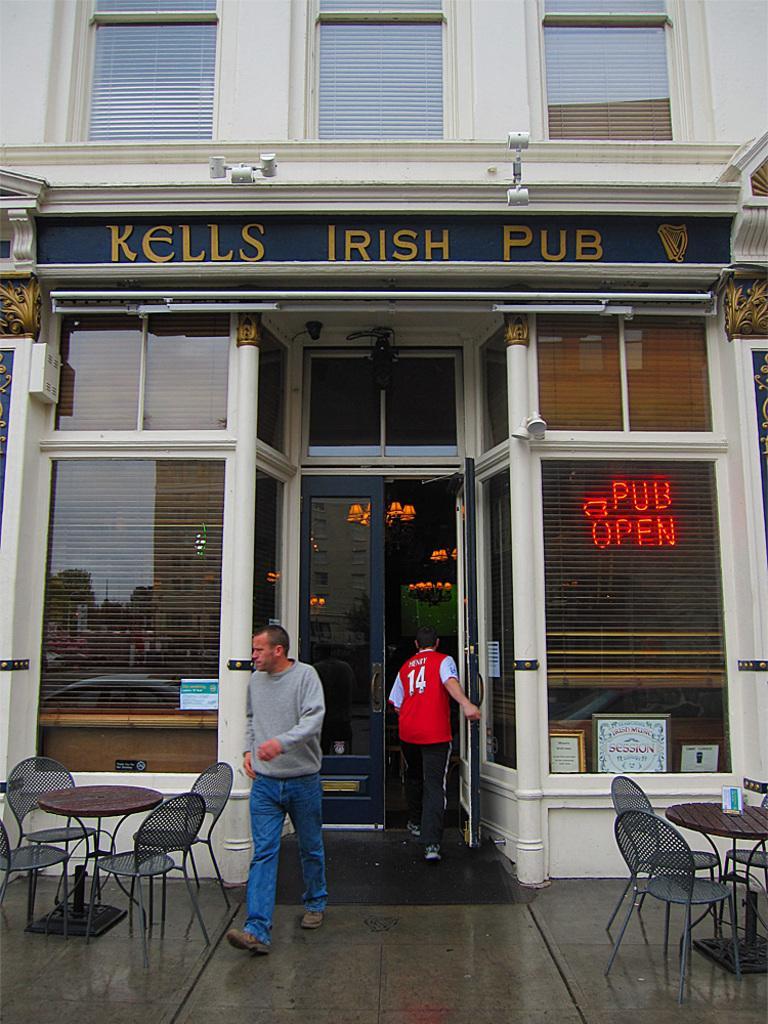Can you describe this image briefly? In this image i can see few chair and a table, there are two persons walking at the back ground i can see a store, a window. 